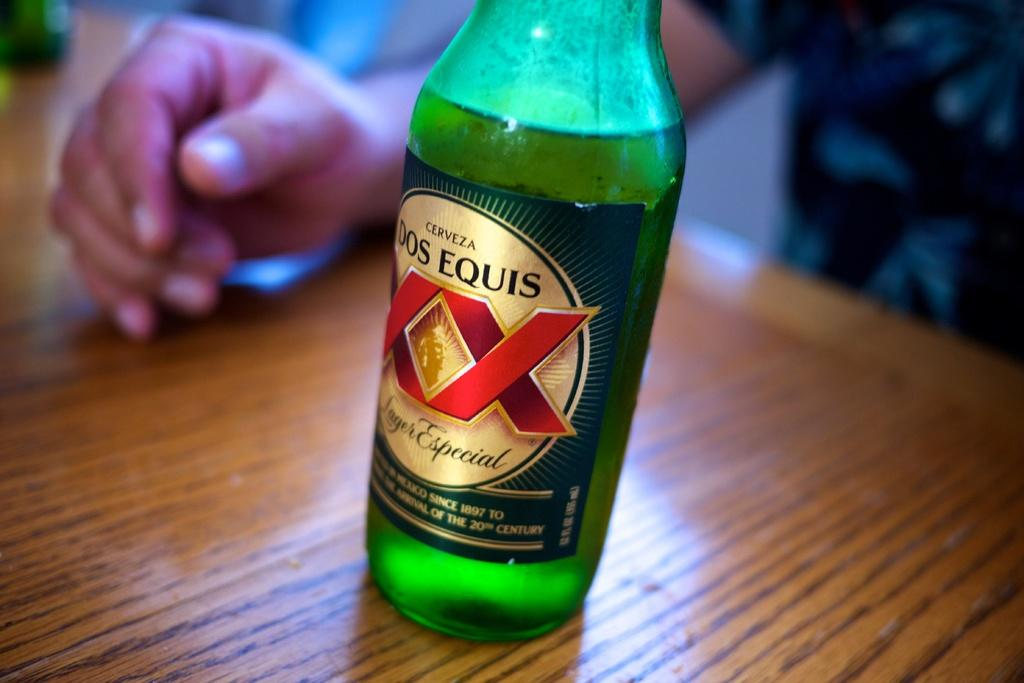What object can be seen in the image? There is a bottle in the image. What part of a person is visible in the image? A human hand is visible in the image. Where are the bottle and the hand located? The bottle and the hand are on a table. What type of popcorn is being served in the image? There is no popcorn present in the image. 